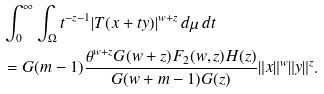Convert formula to latex. <formula><loc_0><loc_0><loc_500><loc_500>& \int _ { 0 } ^ { \infty } \int _ { \Omega } t ^ { - z - 1 } | T ( x + t y ) | ^ { w + z } \, d \mu \, d t \\ & = G ( m - 1 ) \frac { \theta ^ { w + z } G ( w + z ) F _ { 2 } ( w , z ) H ( z ) } { G ( w + m - 1 ) G ( z ) } \| x \| ^ { w } \| y \| ^ { z } .</formula> 